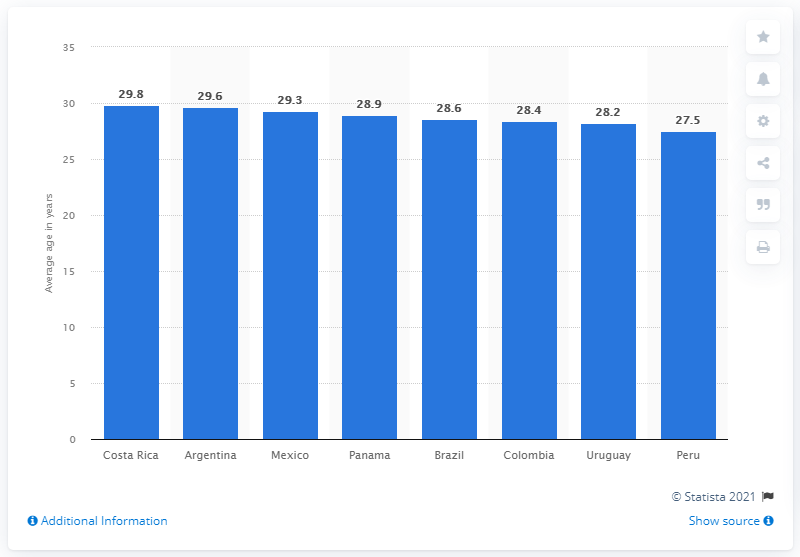Draw attention to some important aspects in this diagram. Costa Rica's soccer team had the oldest average age among all Latin American teams, making it a notable contender in the sport. 